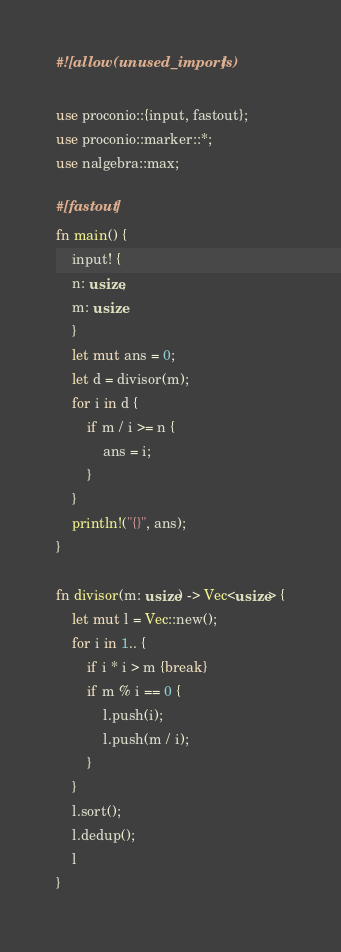Convert code to text. <code><loc_0><loc_0><loc_500><loc_500><_Rust_>#![allow(unused_imports)]

use proconio::{input, fastout};
use proconio::marker::*;
use nalgebra::max;

#[fastout]
fn main() {
    input! {
    n: usize,
    m: usize
    }
    let mut ans = 0;
    let d = divisor(m);
    for i in d {
        if m / i >= n {
            ans = i;
        }
    }
    println!("{}", ans);
}

fn divisor(m: usize) -> Vec<usize> {
    let mut l = Vec::new();
    for i in 1.. {
        if i * i > m {break}
        if m % i == 0 {
            l.push(i);
            l.push(m / i);
        }
    }
    l.sort();
    l.dedup();
    l
}
</code> 